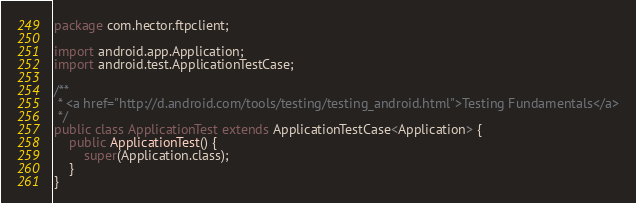Convert code to text. <code><loc_0><loc_0><loc_500><loc_500><_Java_>package com.hector.ftpclient;

import android.app.Application;
import android.test.ApplicationTestCase;

/**
 * <a href="http://d.android.com/tools/testing/testing_android.html">Testing Fundamentals</a>
 */
public class ApplicationTest extends ApplicationTestCase<Application> {
    public ApplicationTest() {
        super(Application.class);
    }
}</code> 